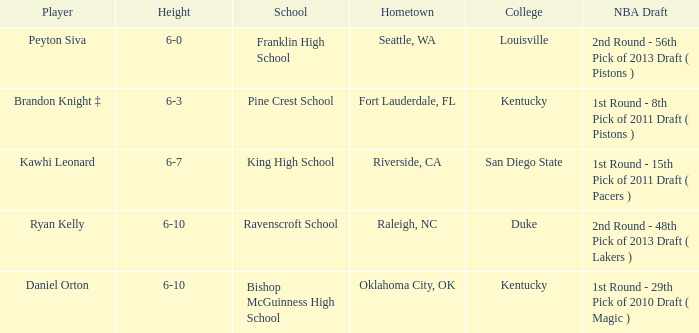How tall is Daniel Orton? 6-10. 